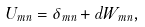<formula> <loc_0><loc_0><loc_500><loc_500>U _ { m n } = \delta _ { m n } + d W _ { m n } ,</formula> 